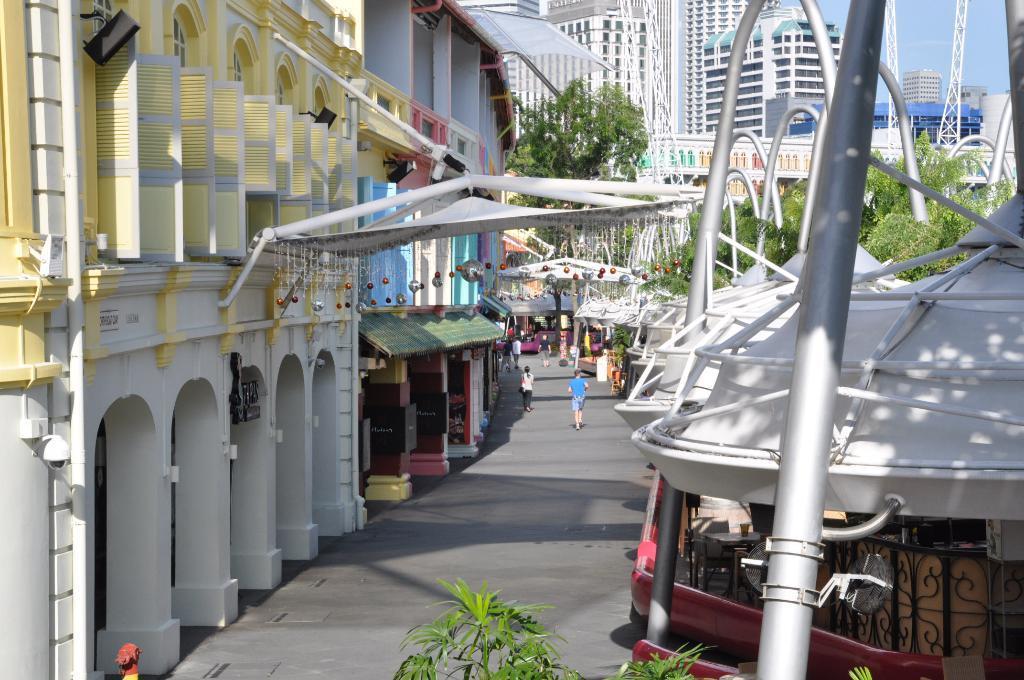In one or two sentences, can you explain what this image depicts? In this image I can see a path in the centre and on it I can see few people are walking. On the right side of this image I can see number of iron poles and white colour things. On the bottom side of this image I can see few plants. I can also see number of buildings, number of trees and the sky in the background. On the top left side of this image I can see a black colour thing on the building. 